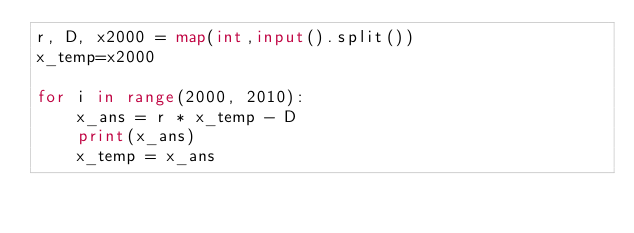Convert code to text. <code><loc_0><loc_0><loc_500><loc_500><_Python_>r, D, x2000 = map(int,input().split())
x_temp=x2000

for i in range(2000, 2010):
    x_ans = r * x_temp - D
    print(x_ans)
    x_temp = x_ans</code> 